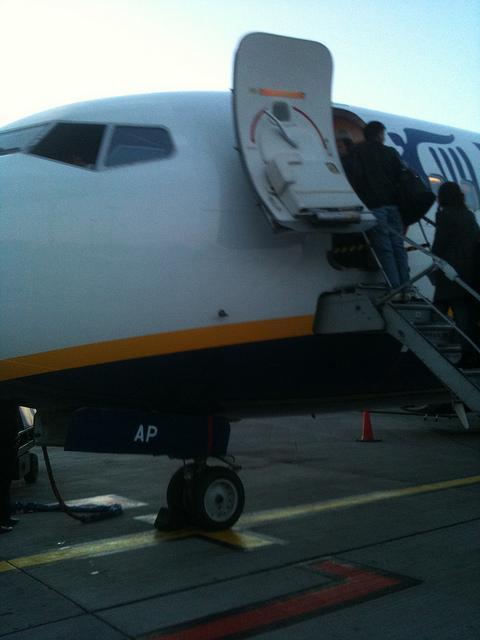How many people are there?
Give a very brief answer. 2. 